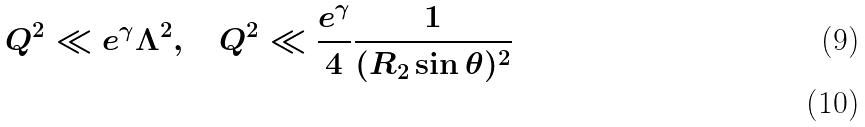<formula> <loc_0><loc_0><loc_500><loc_500>Q ^ { 2 } \ll e ^ { \gamma } \Lambda ^ { 2 } , \quad Q ^ { 2 } \ll \frac { e ^ { \gamma } } { 4 } \frac { 1 } { ( R _ { 2 } \sin \theta ) ^ { 2 } } \\</formula> 